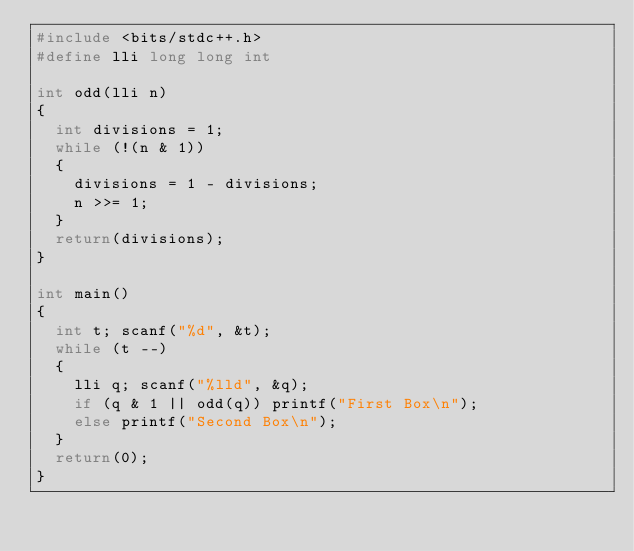Convert code to text. <code><loc_0><loc_0><loc_500><loc_500><_C++_>#include <bits/stdc++.h>
#define lli long long int

int odd(lli n)
{
  int divisions = 1;
  while (!(n & 1))
  {
    divisions = 1 - divisions;
    n >>= 1;
  }
  return(divisions);
}

int main()
{
  int t; scanf("%d", &t);
  while (t --)
  {
    lli q; scanf("%lld", &q);
    if (q & 1 || odd(q)) printf("First Box\n");
    else printf("Second Box\n");
  }
  return(0);
}
</code> 